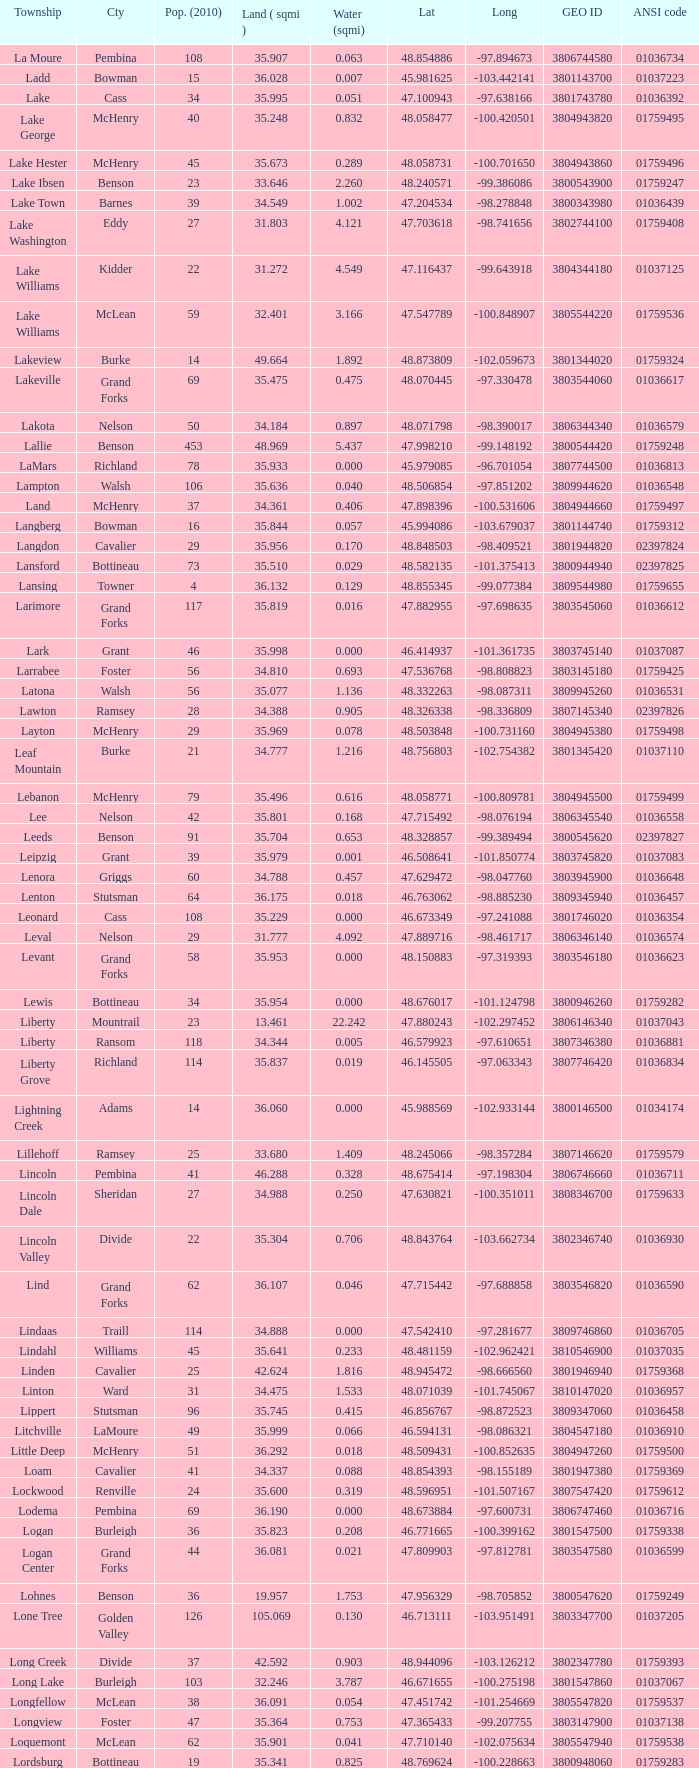What is latitude when 2010 population is 24 and water is more than 0.319? None. 